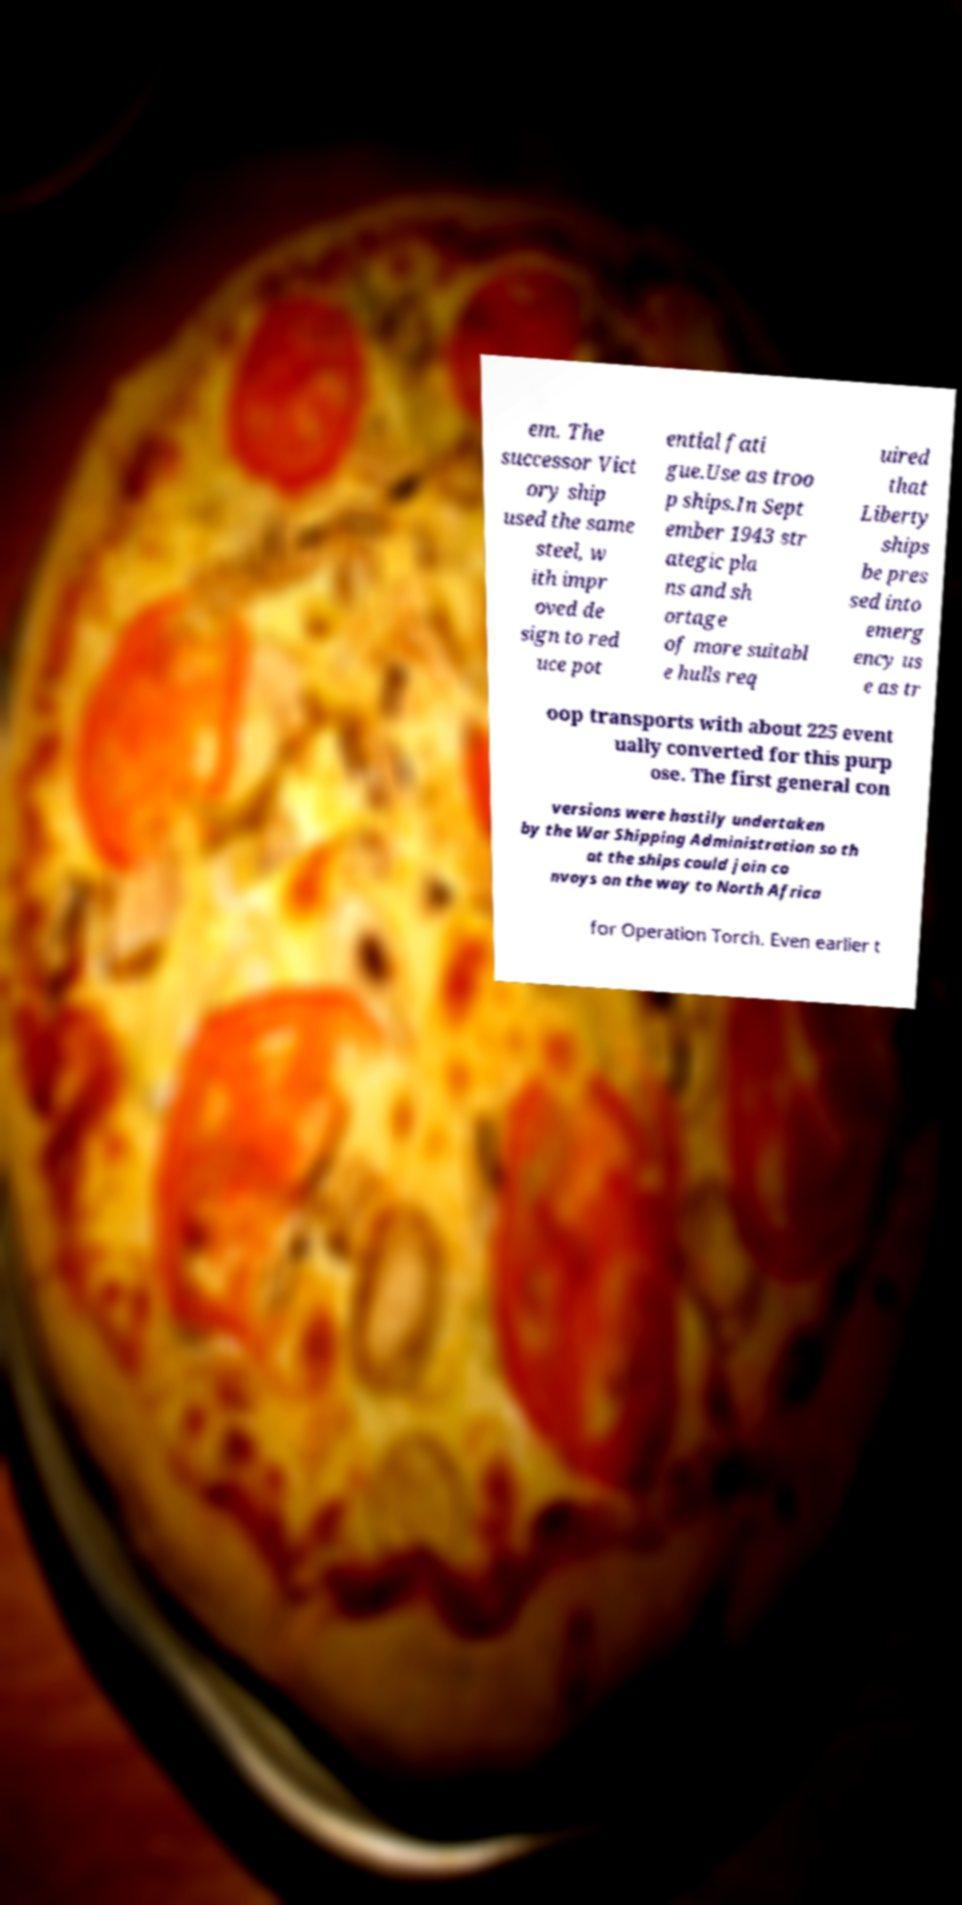Could you assist in decoding the text presented in this image and type it out clearly? em. The successor Vict ory ship used the same steel, w ith impr oved de sign to red uce pot ential fati gue.Use as troo p ships.In Sept ember 1943 str ategic pla ns and sh ortage of more suitabl e hulls req uired that Liberty ships be pres sed into emerg ency us e as tr oop transports with about 225 event ually converted for this purp ose. The first general con versions were hastily undertaken by the War Shipping Administration so th at the ships could join co nvoys on the way to North Africa for Operation Torch. Even earlier t 